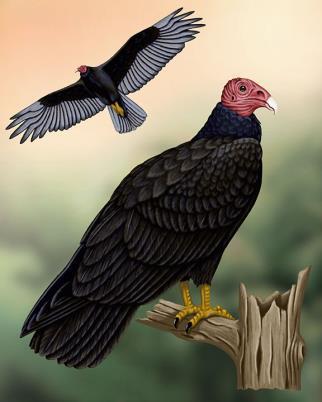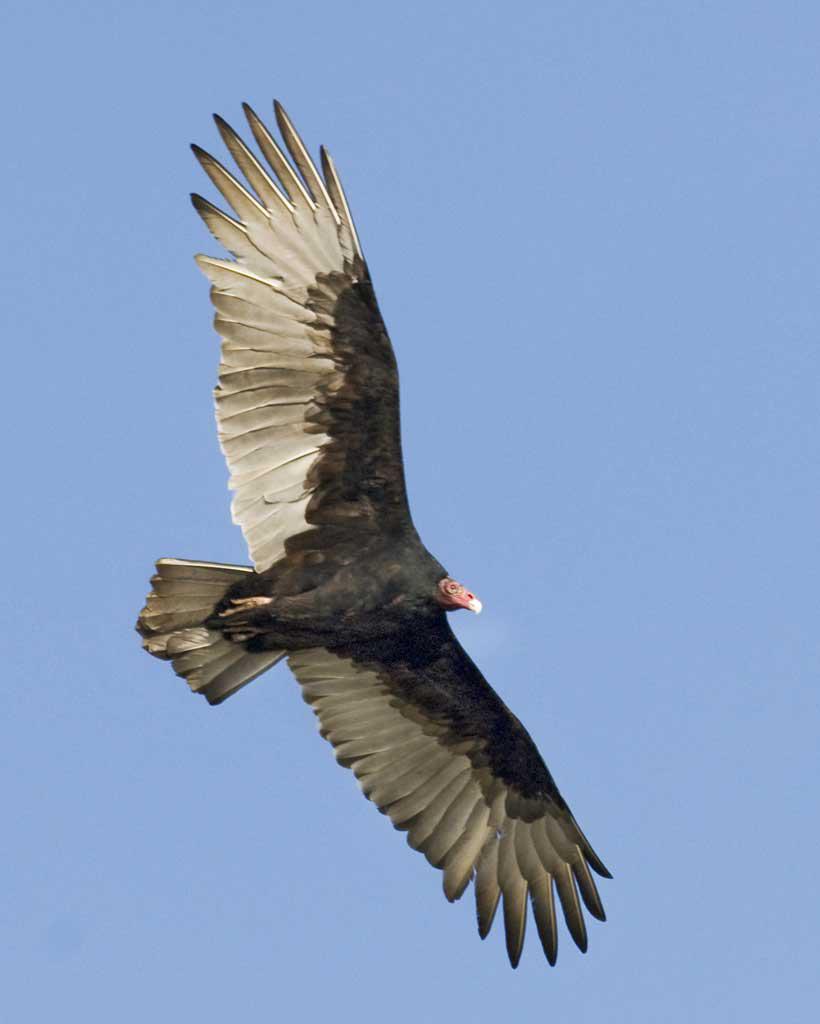The first image is the image on the left, the second image is the image on the right. Assess this claim about the two images: "The vulture on the right image is flying facing right.". Correct or not? Answer yes or no. Yes. The first image is the image on the left, the second image is the image on the right. Given the left and right images, does the statement "A total of three vultures are shown." hold true? Answer yes or no. Yes. 